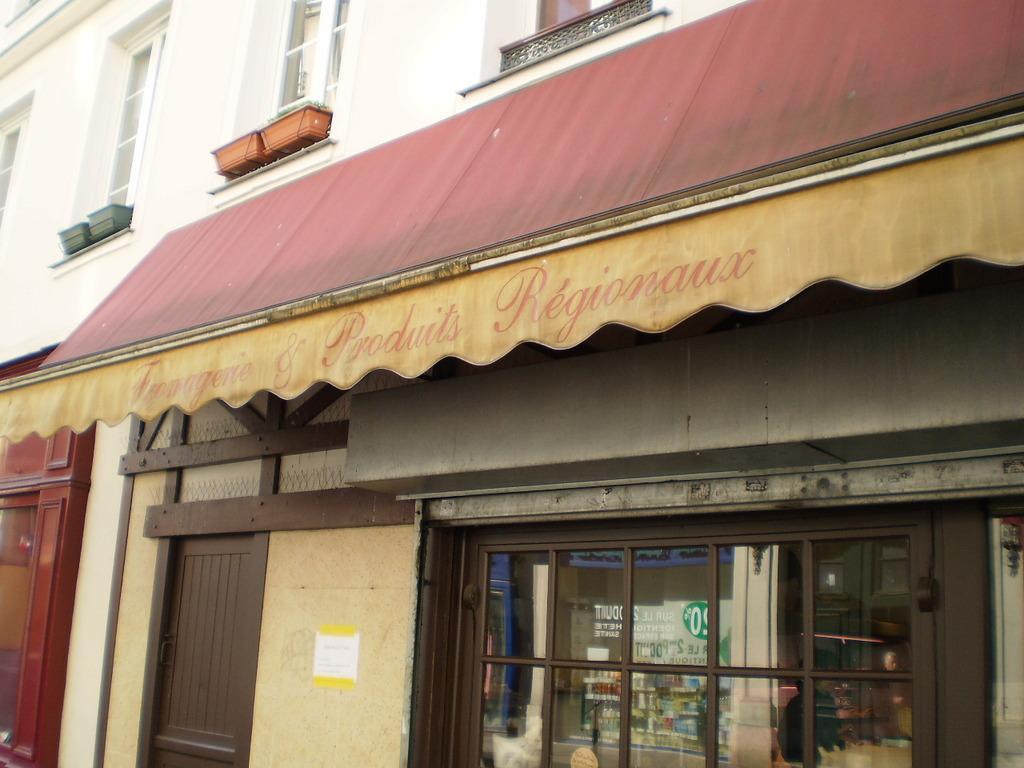In one or two sentences, can you explain what this image depicts? In this picture we can see some buildings and we can see some the glass wall. 